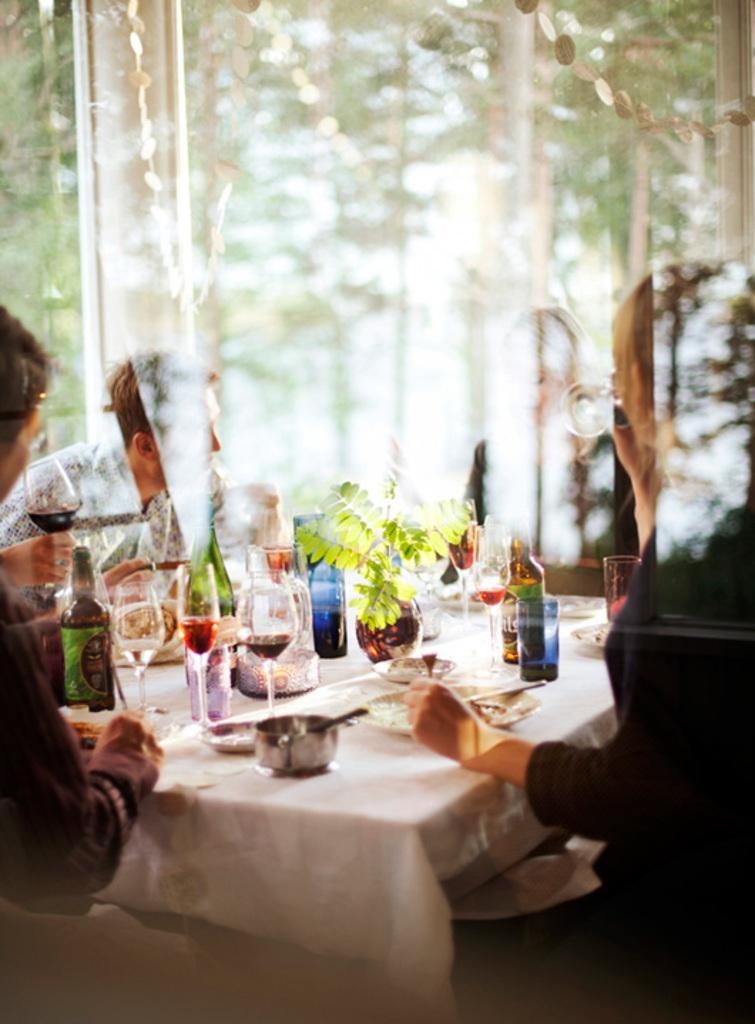What piece of furniture is present in the image? There is a table in the image. What items can be seen on the table? There are glasses, bottles, plates, and cups on the table. Are there any people in the image? Yes, there are people sitting on chairs around the table. What is the condition of the background in the image? The background of the image is blurred. What type of advice does the manager give to the father in the image? There is no manager or father present in the image, and therefore no such interaction can be observed. 